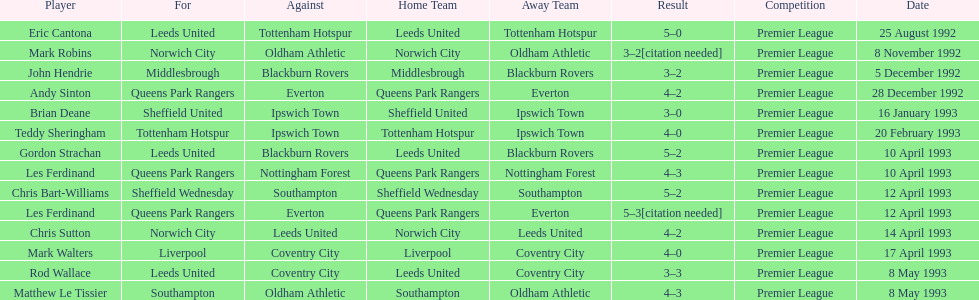In the 1992-1993 premier league, what was the total number of hat tricks scored by all players? 14. 